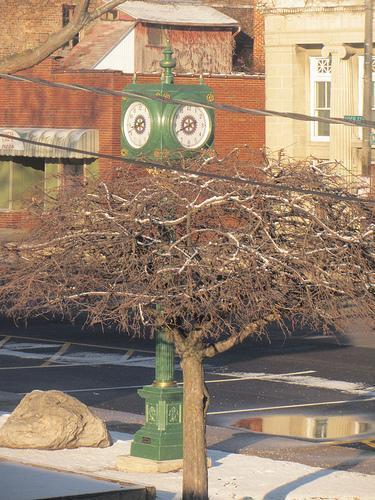How many clock faces can be seen?
Give a very brief answer. 2. 